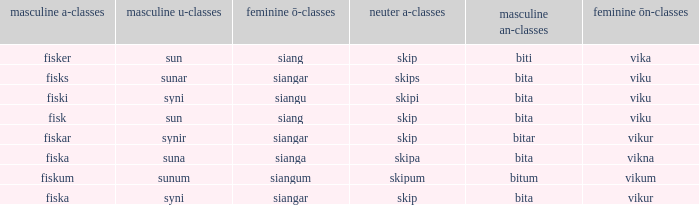What is the u form of the word with a neuter form of skip and a masculine a-ending of fisker? Sun. 